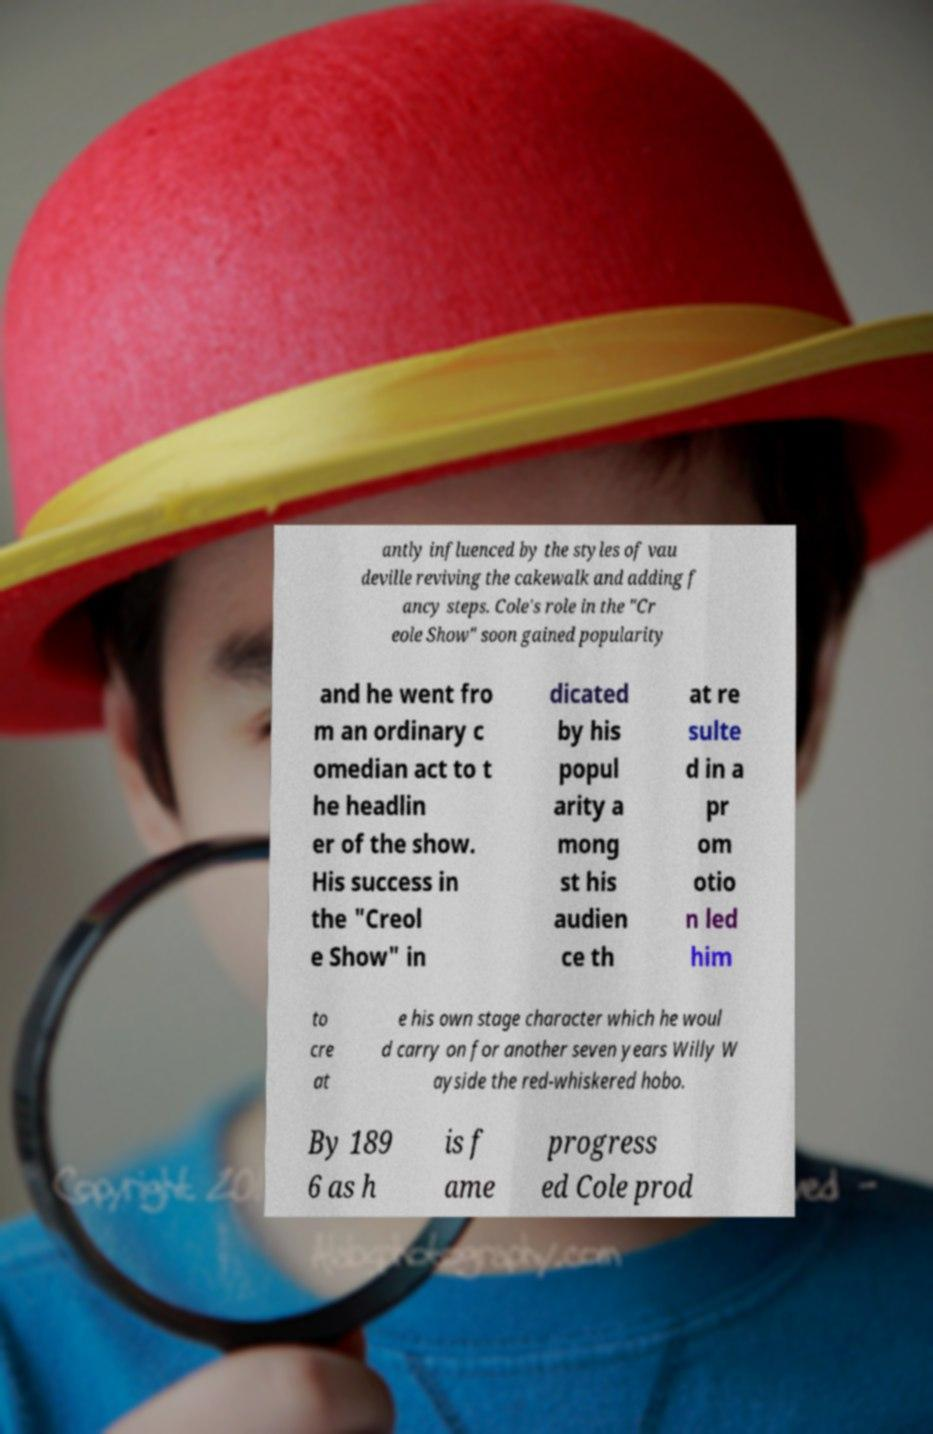There's text embedded in this image that I need extracted. Can you transcribe it verbatim? antly influenced by the styles of vau deville reviving the cakewalk and adding f ancy steps. Cole's role in the "Cr eole Show" soon gained popularity and he went fro m an ordinary c omedian act to t he headlin er of the show. His success in the "Creol e Show" in dicated by his popul arity a mong st his audien ce th at re sulte d in a pr om otio n led him to cre at e his own stage character which he woul d carry on for another seven years Willy W ayside the red-whiskered hobo. By 189 6 as h is f ame progress ed Cole prod 